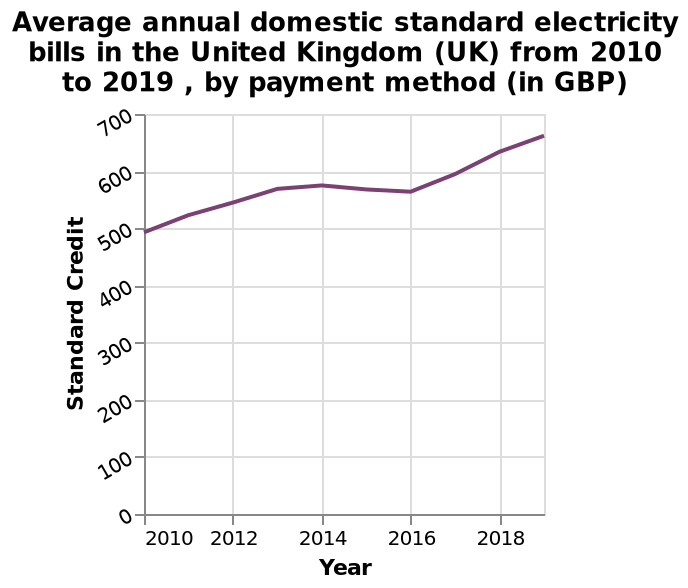<image>
Is there any significant dip in the standard credit scores between 2014-16?  Yes, there is a very small dip in the standard credit scores between 2014-16. What is the highest standard credit score observed from 2010 to 2019? The highest standard credit score observed from 2010 to 2019 is over 650. 